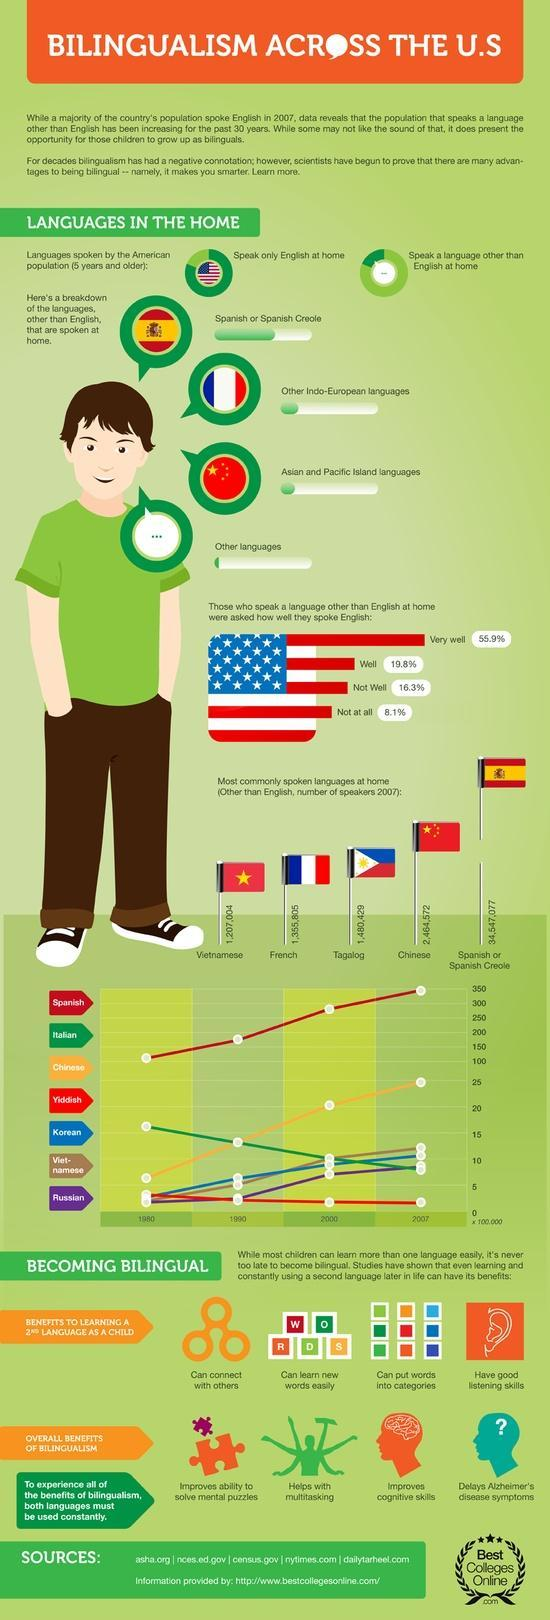What makes you smarter?
Answer the question with a short phrase. Bilingualism What percent of people did not speak english at all? 8.1% which is the second most spoken language other than english in 2007? Chinese Which languages are being spoken by lesser number of people as years go from 1980 to 2007? yiddish,Italian which is the fourth most spoken language other than english in 2007? French which is the fifth most spoken language other than english in 2007? Vietnamese 